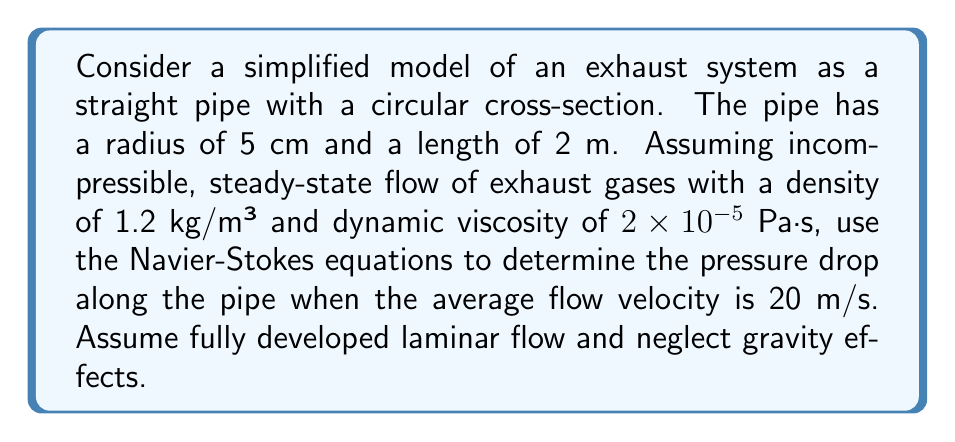Can you solve this math problem? As an automotive engineer, let's approach this problem step-by-step using the Navier-Stokes equations for incompressible, steady-state flow in a pipe:

1) For fully developed laminar flow in a pipe, we can simplify the Navier-Stokes equations to:

   $$\frac{dp}{dx} = \mu \frac{1}{r} \frac{d}{dr}\left(r\frac{du}{dr}\right)$$

   where $p$ is pressure, $x$ is the axial direction, $\mu$ is dynamic viscosity, $r$ is the radial coordinate, and $u$ is the axial velocity.

2) The solution to this equation for the velocity profile is:

   $$u(r) = \frac{1}{4\mu} \frac{dp}{dx} (R^2 - r^2)$$

   where $R$ is the pipe radius.

3) The average velocity $\bar{u}$ is related to the pressure gradient by:

   $$\bar{u} = -\frac{R^2}{8\mu} \frac{dp}{dx}$$

4) Rearranging this equation:

   $$\frac{dp}{dx} = -\frac{8\mu\bar{u}}{R^2}$$

5) Now, let's plug in our values:
   $\mu = 2 \times 10^{-5}$ Pa·s
   $\bar{u} = 20$ m/s
   $R = 0.05$ m

   $$\frac{dp}{dx} = -\frac{8(2 \times 10^{-5})(20)}{(0.05)^2} = -2560 \text{ Pa/m}$$

6) To find the total pressure drop over the length of the pipe:

   $$\Delta p = \frac{dp}{dx} \cdot L = -2560 \cdot 2 = -5120 \text{ Pa}$$

The negative sign indicates that pressure decreases along the flow direction.
Answer: The pressure drop along the 2 m exhaust pipe is 5120 Pa. 